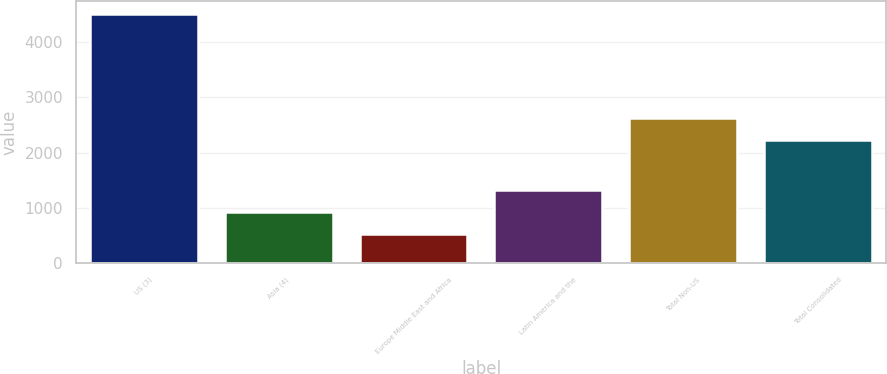<chart> <loc_0><loc_0><loc_500><loc_500><bar_chart><fcel>US (3)<fcel>Asia (4)<fcel>Europe Middle East and Africa<fcel>Latin America and the<fcel>Total Non-US<fcel>Total Consolidated<nl><fcel>4511<fcel>923.6<fcel>525<fcel>1322.2<fcel>2636.6<fcel>2238<nl></chart> 